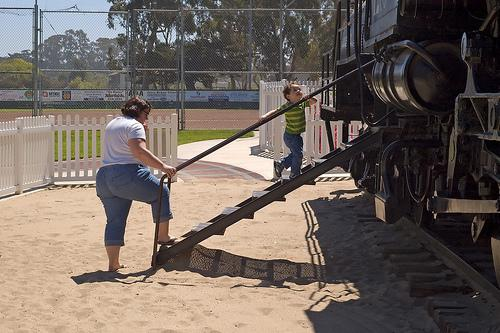Question: where is this picture taken?
Choices:
A. Outside near a field.
B. At the zoo.
C. At the amusement park.
D. At the diner.
Answer with the letter. Answer: A Question: who the adult in the picture?
Choices:
A. The pilot.
B. My uncle.
C. A woman.
D. Her grandfather.
Answer with the letter. Answer: C Question: what kind of pants does the woman have on?
Choices:
A. Suede.
B. Cargo pants.
C. Corduroy pants.
D. Jeans.
Answer with the letter. Answer: D Question: how many people are in this picture?
Choices:
A. 4.
B. 5.
C. 6.
D. 2.
Answer with the letter. Answer: D Question: what is the woman standing on?
Choices:
A. Sand.
B. Grass.
C. Mud.
D. A rock.
Answer with the letter. Answer: A 